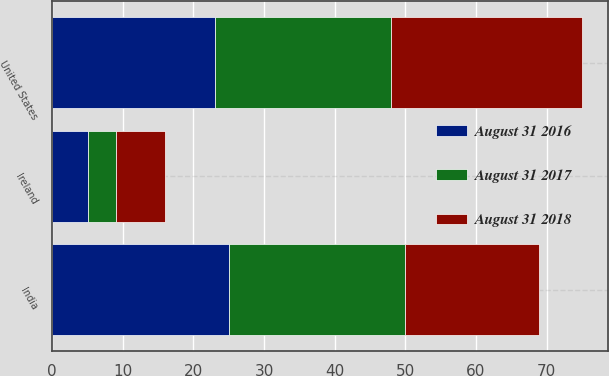Convert chart. <chart><loc_0><loc_0><loc_500><loc_500><stacked_bar_chart><ecel><fcel>United States<fcel>India<fcel>Ireland<nl><fcel>August 31 2018<fcel>27<fcel>19<fcel>7<nl><fcel>August 31 2016<fcel>23<fcel>25<fcel>5<nl><fcel>August 31 2017<fcel>25<fcel>25<fcel>4<nl></chart> 